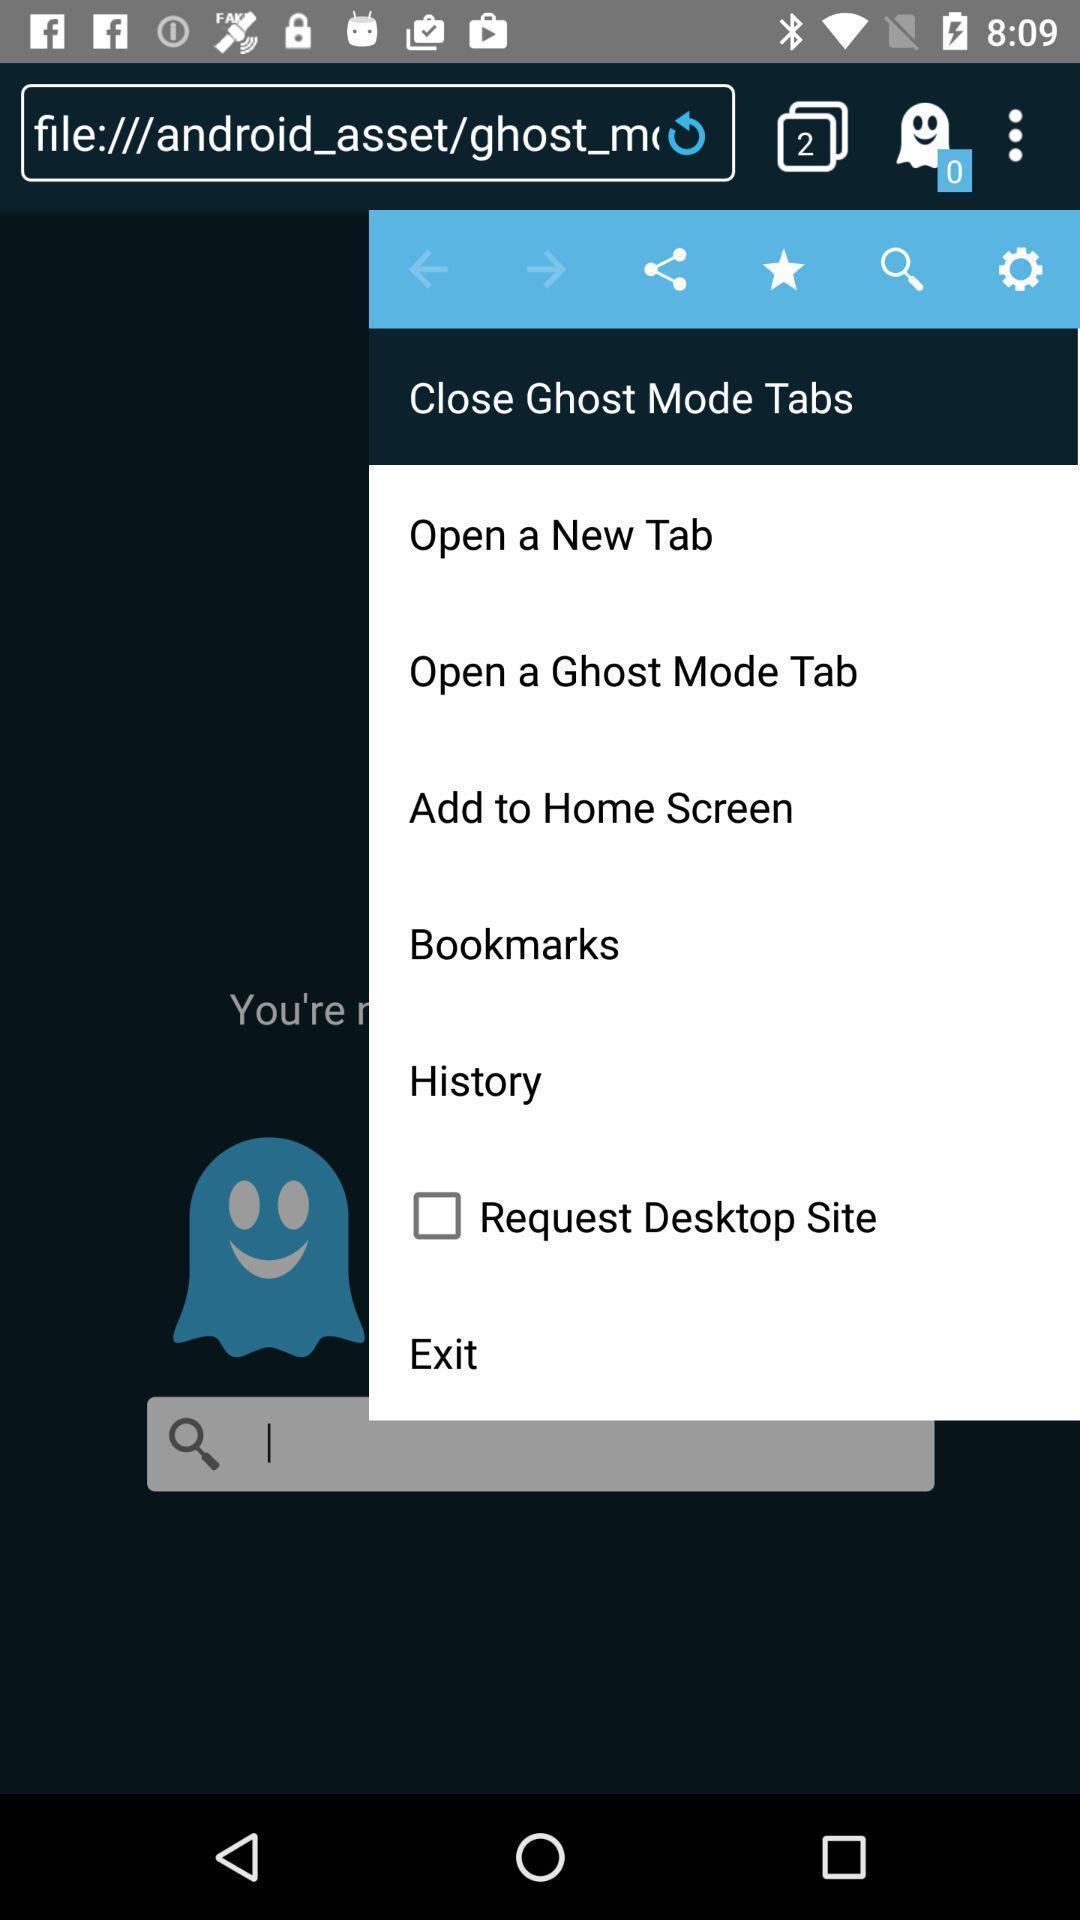Provide a textual representation of this image. Screen shows settings of different tabs. 